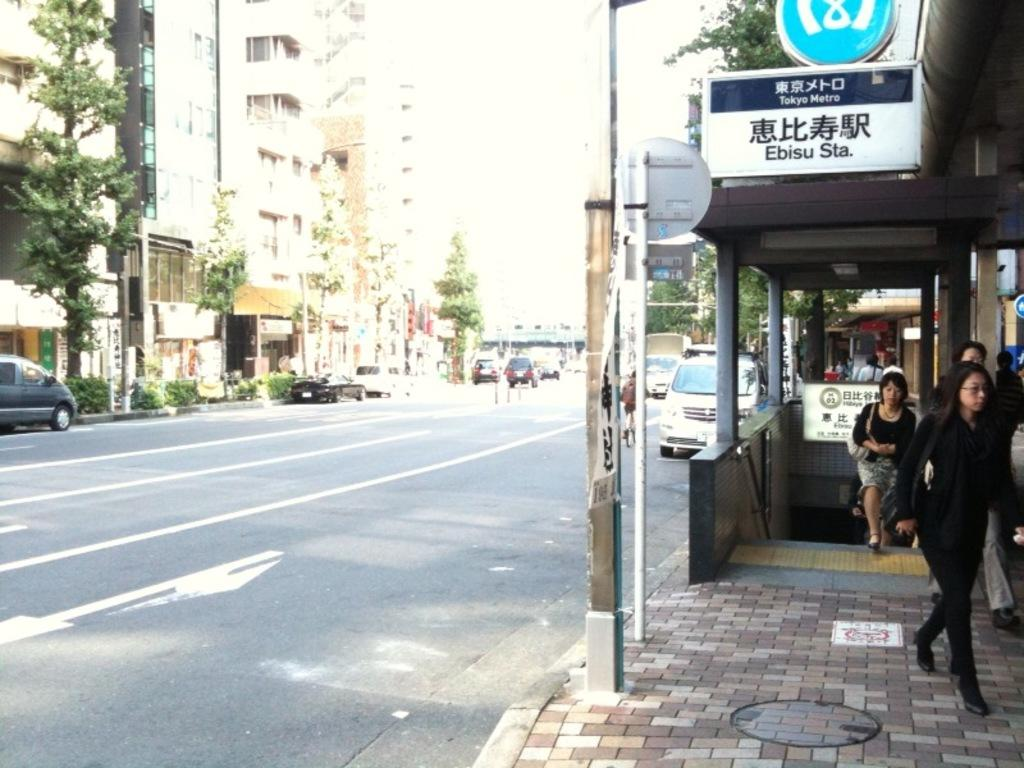<image>
Create a compact narrative representing the image presented. People are going out of Ebisu station which is next to an empty street. 